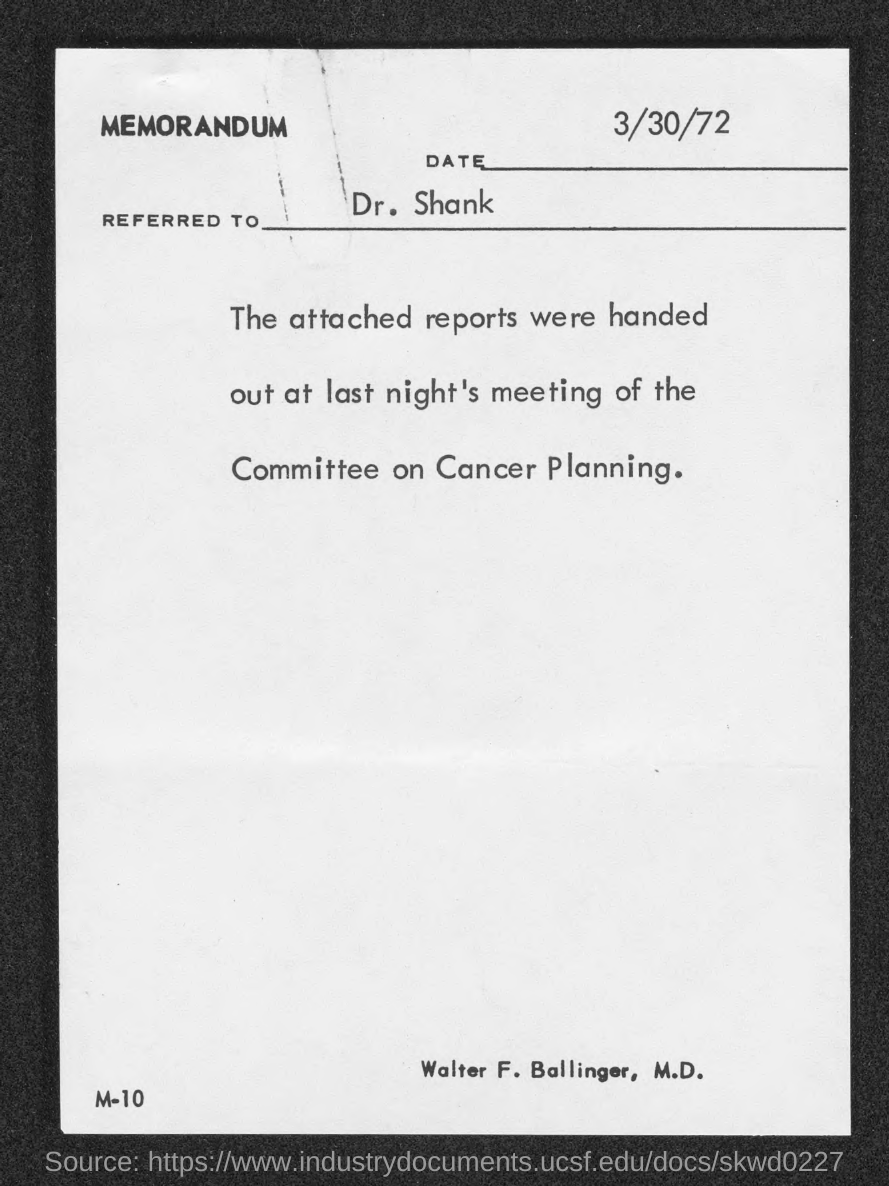Specify some key components in this picture. The memorandum is addressed to Dr. Shank. The memorandum mentions that the date is March 30, 1972. 